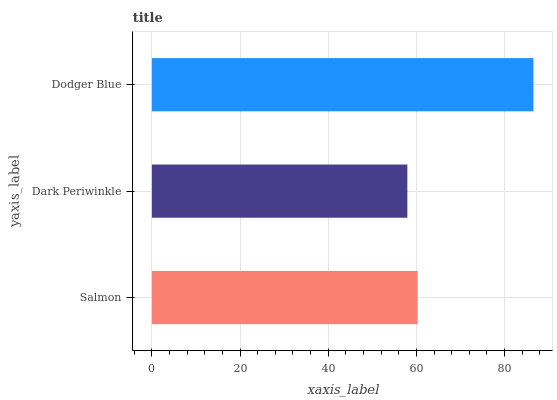Is Dark Periwinkle the minimum?
Answer yes or no. Yes. Is Dodger Blue the maximum?
Answer yes or no. Yes. Is Dodger Blue the minimum?
Answer yes or no. No. Is Dark Periwinkle the maximum?
Answer yes or no. No. Is Dodger Blue greater than Dark Periwinkle?
Answer yes or no. Yes. Is Dark Periwinkle less than Dodger Blue?
Answer yes or no. Yes. Is Dark Periwinkle greater than Dodger Blue?
Answer yes or no. No. Is Dodger Blue less than Dark Periwinkle?
Answer yes or no. No. Is Salmon the high median?
Answer yes or no. Yes. Is Salmon the low median?
Answer yes or no. Yes. Is Dodger Blue the high median?
Answer yes or no. No. Is Dark Periwinkle the low median?
Answer yes or no. No. 